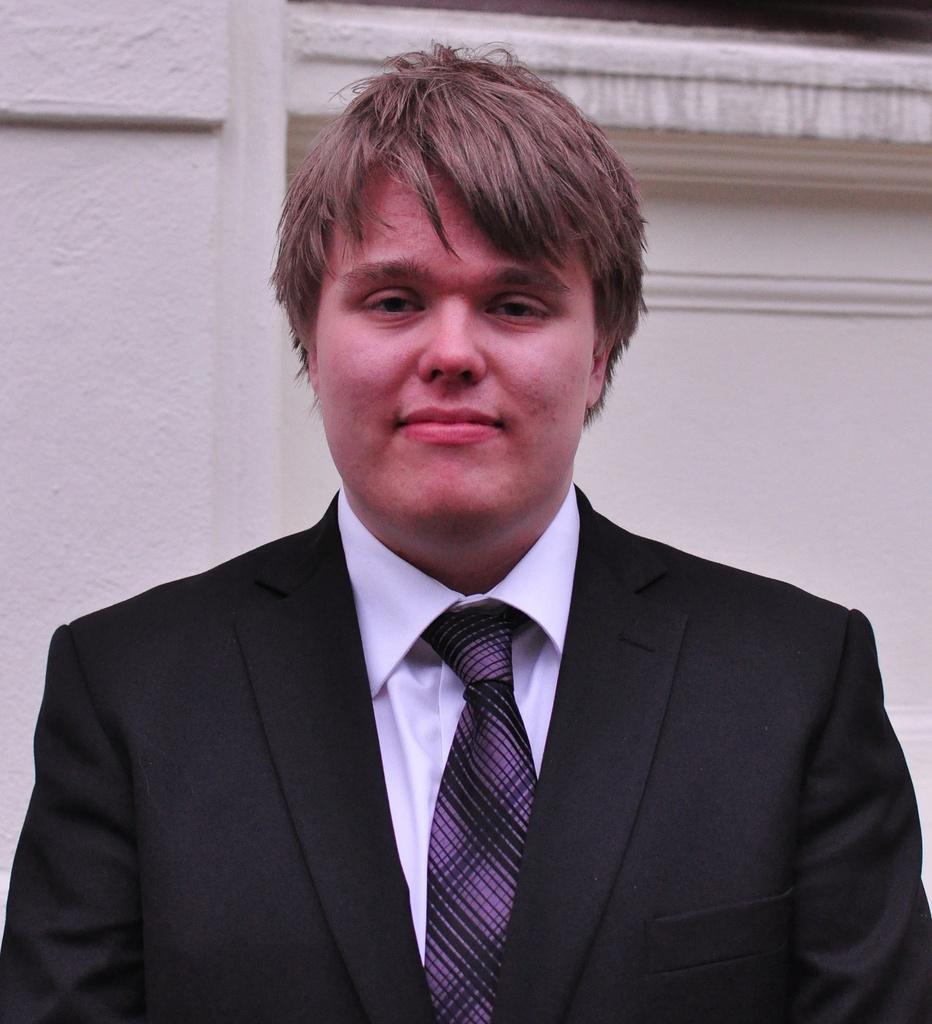Could you give a brief overview of what you see in this image? In the center of the image we can see a man standing. He is wearing a suit. In the background we can see a wall. 